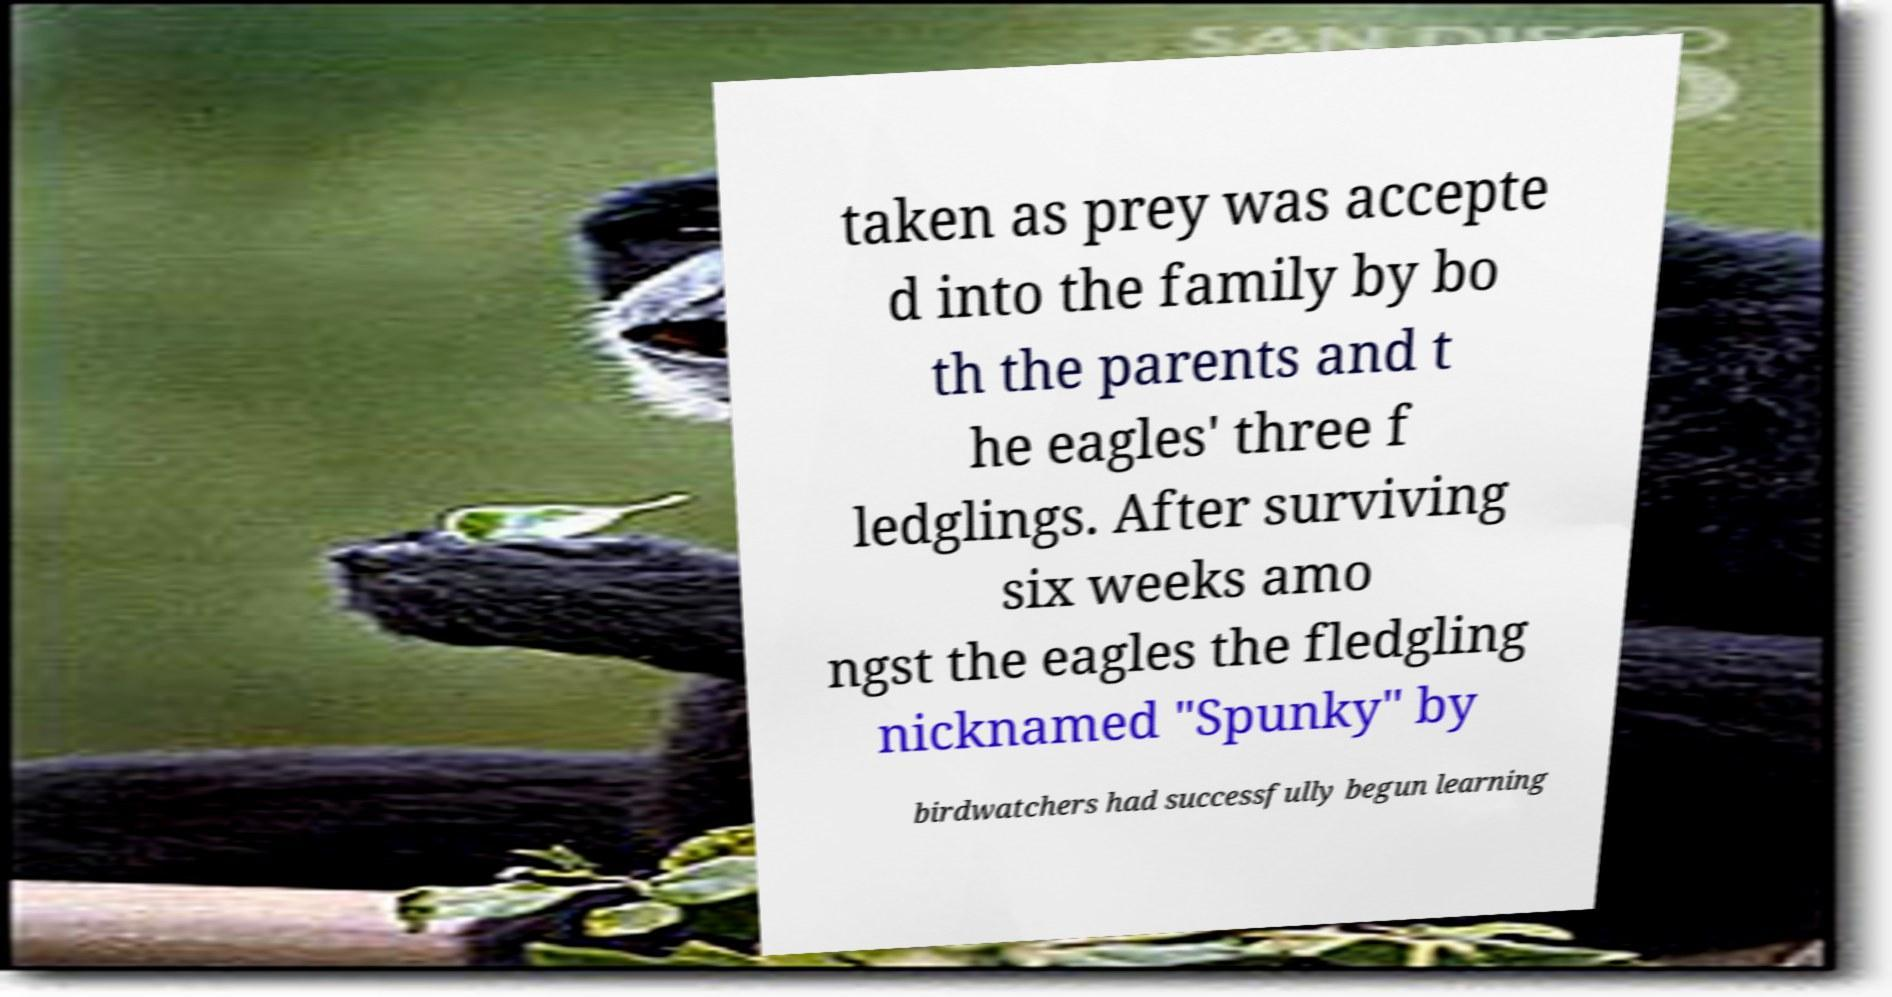What messages or text are displayed in this image? I need them in a readable, typed format. taken as prey was accepte d into the family by bo th the parents and t he eagles' three f ledglings. After surviving six weeks amo ngst the eagles the fledgling nicknamed "Spunky" by birdwatchers had successfully begun learning 